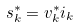Convert formula to latex. <formula><loc_0><loc_0><loc_500><loc_500>s _ { k } ^ { * } = v _ { k } ^ { * } i _ { k }</formula> 